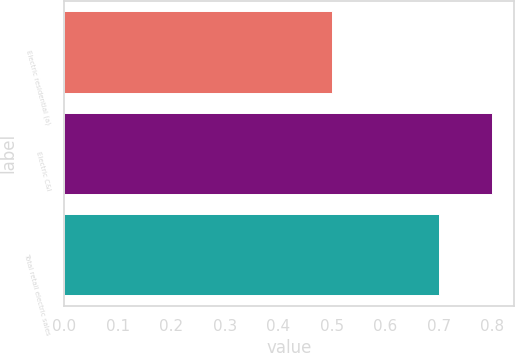Convert chart. <chart><loc_0><loc_0><loc_500><loc_500><bar_chart><fcel>Electric residential (a)<fcel>Electric C&I<fcel>Total retail electric sales<nl><fcel>0.5<fcel>0.8<fcel>0.7<nl></chart> 